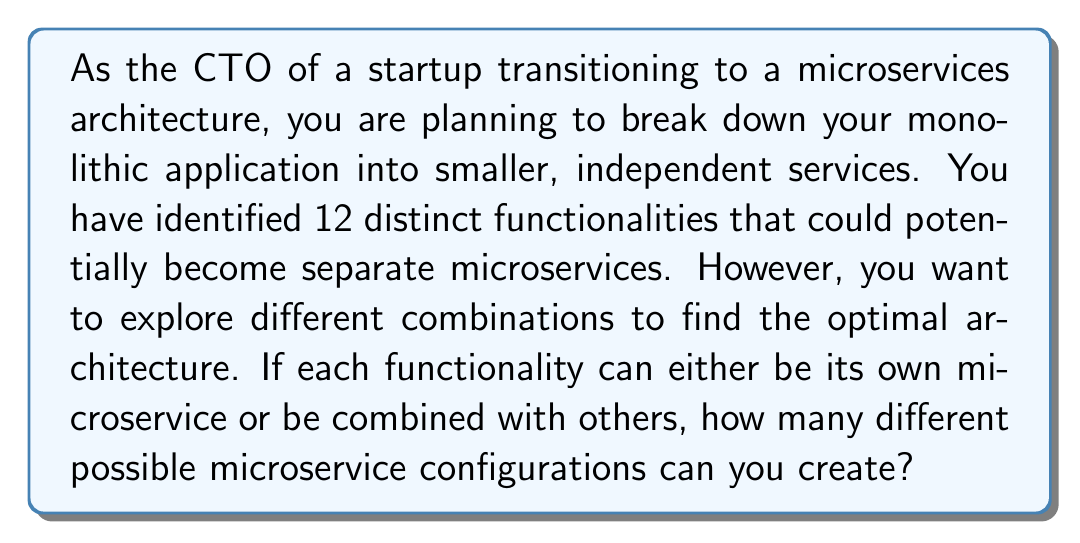Help me with this question. To solve this problem, we need to use the concept of set partitions from number theory. Each possible microservice configuration is essentially a partition of the set of 12 functionalities.

The number of ways to partition a set of n elements is given by the Bell number $B_n$. The Bell numbers can be calculated using the Bell triangle, which is constructed as follows:

1. The first number in each row is the last number of the previous row.
2. Each subsequent number in the row is the sum of the number to its left and the number above the number to its left.

Let's construct the Bell triangle up to $n=12$:

$$
\begin{array}{cccccccccccccc}
1 & & & & & & & & & & & & \\
1 & 2 & & & & & & & & & & & \\
2 & 3 & 5 & & & & & & & & & & \\
5 & 7 & 10 & 15 & & & & & & & & & \\
15 & 20 & 27 & 37 & 52 & & & & & & & & \\
52 & 67 & 87 & 114 & 151 & 203 & & & & & & & \\
203 & 255 & 322 & 409 & 523 & 674 & 877 & & & & & & \\
877 & 1080 & 1335 & 1657 & 2066 & 2589 & 3263 & 4140 & & & & & \\
4140 & 5017 & 6097 & 7432 & 9089 & 11155 & 13744 & 16883 & 21023 & & & & \\
21023 & 25163 & 30180 & 36277 & 43709 & 52798 & 63953 & 77697 & 94580 & 115603 & & & \\
115603 & 136626 & 161789 & 191969 & 228246 & 271955 & 324753 & 388706 & 466403 & 560983 & 676586 & & \\
676586 & 792189 & 928815 & 1090604 & 1282573 & 1510819 & 1782774 & 2107527 & 2496233 & 2962636 & 3523619 & 4200205 &
\end{array}
$$

The last number in the 12th row (which is also the first number in the 13th row) is the Bell number $B_{12}$, which gives us the total number of possible partitions for a set of 12 elements.
Answer: $B_{12} = 4,213,597$ possible microservice configurations 